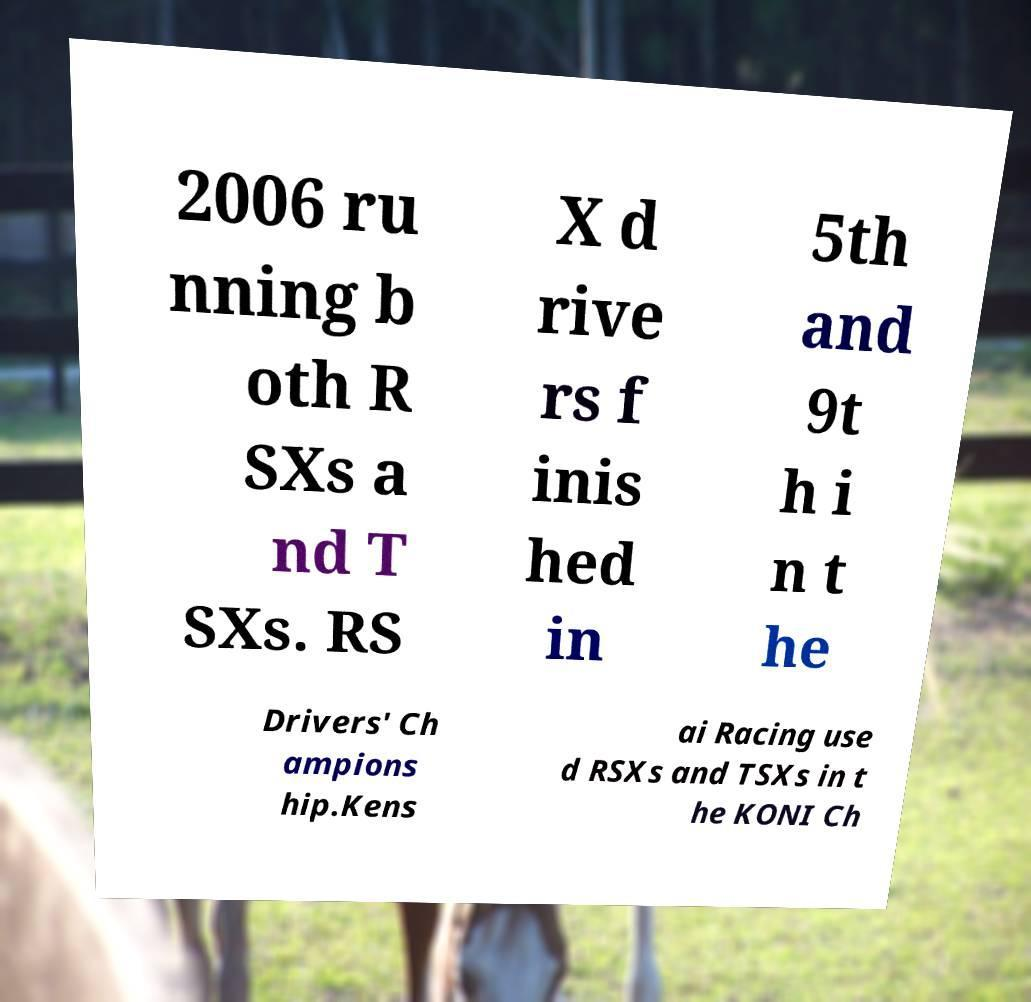Please read and relay the text visible in this image. What does it say? 2006 ru nning b oth R SXs a nd T SXs. RS X d rive rs f inis hed in 5th and 9t h i n t he Drivers' Ch ampions hip.Kens ai Racing use d RSXs and TSXs in t he KONI Ch 